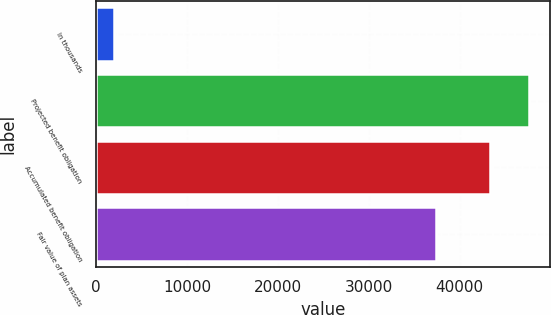Convert chart to OTSL. <chart><loc_0><loc_0><loc_500><loc_500><bar_chart><fcel>In thousands<fcel>Projected benefit obligation<fcel>Accumulated benefit obligation<fcel>Fair value of plan assets<nl><fcel>2017<fcel>47559.6<fcel>43340<fcel>37432<nl></chart> 